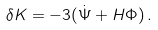<formula> <loc_0><loc_0><loc_500><loc_500>\delta K = - 3 ( \dot { \Psi } + H \Phi ) \, .</formula> 